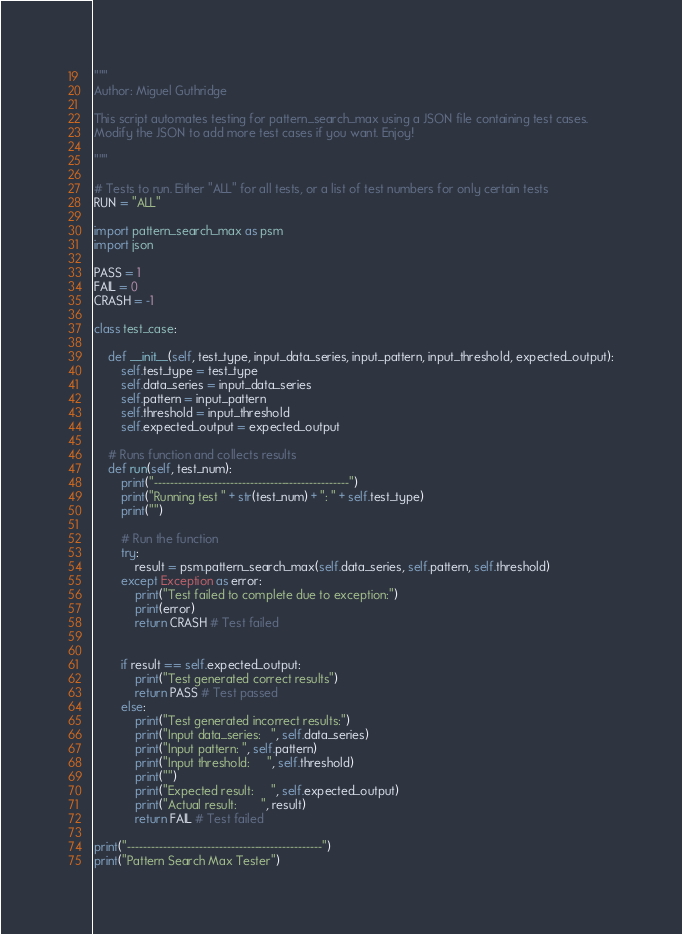Convert code to text. <code><loc_0><loc_0><loc_500><loc_500><_Python_>"""
Author: Miguel Guthridge

This script automates testing for pattern_search_max using a JSON file containing test cases.
Modify the JSON to add more test cases if you want. Enjoy!

"""

# Tests to run. Either "ALL" for all tests, or a list of test numbers for only certain tests
RUN = "ALL"

import pattern_search_max as psm
import json

PASS = 1
FAIL = 0
CRASH = -1

class test_case:

    def __init__(self, test_type, input_data_series, input_pattern, input_threshold, expected_output):
        self.test_type = test_type
        self.data_series = input_data_series
        self.pattern = input_pattern
        self.threshold = input_threshold
        self.expected_output = expected_output
    
    # Runs function and collects results
    def run(self, test_num):
        print("-------------------------------------------------")
        print("Running test " + str(test_num) + ": " + self.test_type)
        print("")

        # Run the function
        try:
            result = psm.pattern_search_max(self.data_series, self.pattern, self.threshold)
        except Exception as error:
            print("Test failed to complete due to exception:")
            print(error)
            return CRASH # Test failed
        

        if result == self.expected_output:
            print("Test generated correct results")
            return PASS # Test passed
        else:
            print("Test generated incorrect results:")
            print("Input data_series:   ", self.data_series)
            print("Input pattern: ", self.pattern)
            print("Input threshold:     ", self.threshold)
            print("")
            print("Expected result:     ", self.expected_output)
            print("Actual result:       ", result)
            return FAIL # Test failed

print("-------------------------------------------------")
print("Pattern Search Max Tester")</code> 